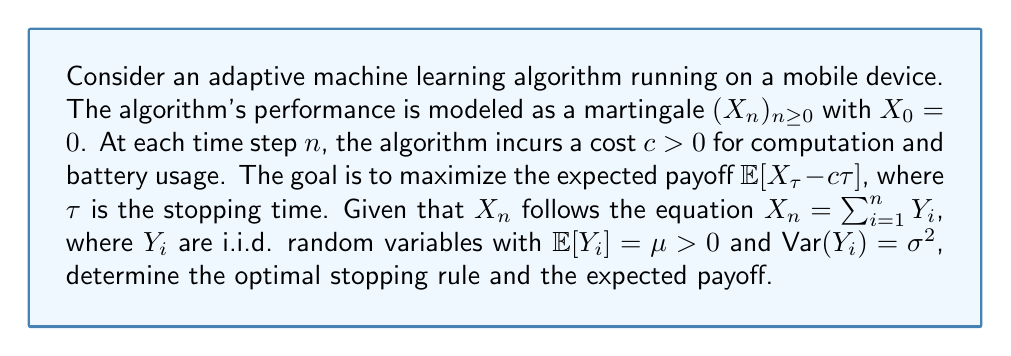Provide a solution to this math problem. To solve this problem, we'll use the optimal stopping theory for martingales:

1) First, we need to check if the sequence $(X_n - cn)_{n\geq0}$ is a supermartingale:
   
   $\mathbb{E}[X_{n+1} - c(n+1) | \mathcal{F}_n] = \mathbb{E}[X_n + Y_{n+1} - cn - c | \mathcal{F}_n]$
   $= X_n - cn + \mathbb{E}[Y_{n+1}] - c = X_n - cn + \mu - c$

   It's a supermartingale if $\mu - c \leq 0$, or $\mu \leq c$.

2) If $\mu > c$, the sequence is not a supermartingale, and the optimal strategy is to never stop.

3) If $\mu \leq c$, we can apply the optimal stopping theorem. The optimal stopping rule is to stop when:

   $X_n - cn \geq \mathbb{E}[X_{n+1} - c(n+1) | \mathcal{F}_n]$

4) Substituting the expectation:

   $X_n - cn \geq X_n + \mu - c(n+1)$
   $0 \geq \mu - c$

5) This inequality is always true when $\mu \leq c$. Therefore, the optimal stopping rule is to stop immediately (at $n=0$).

6) The expected payoff is:

   $\mathbb{E}[X_0 - c \cdot 0] = 0$

In summary:
- If $\mu > c$, never stop. The expected payoff grows indefinitely.
- If $\mu \leq c$, stop immediately. The expected payoff is 0.
Answer: If $\mu > c$, never stop; if $\mu \leq c$, stop immediately. Expected payoff: $\max\{0, \infty\}$. 